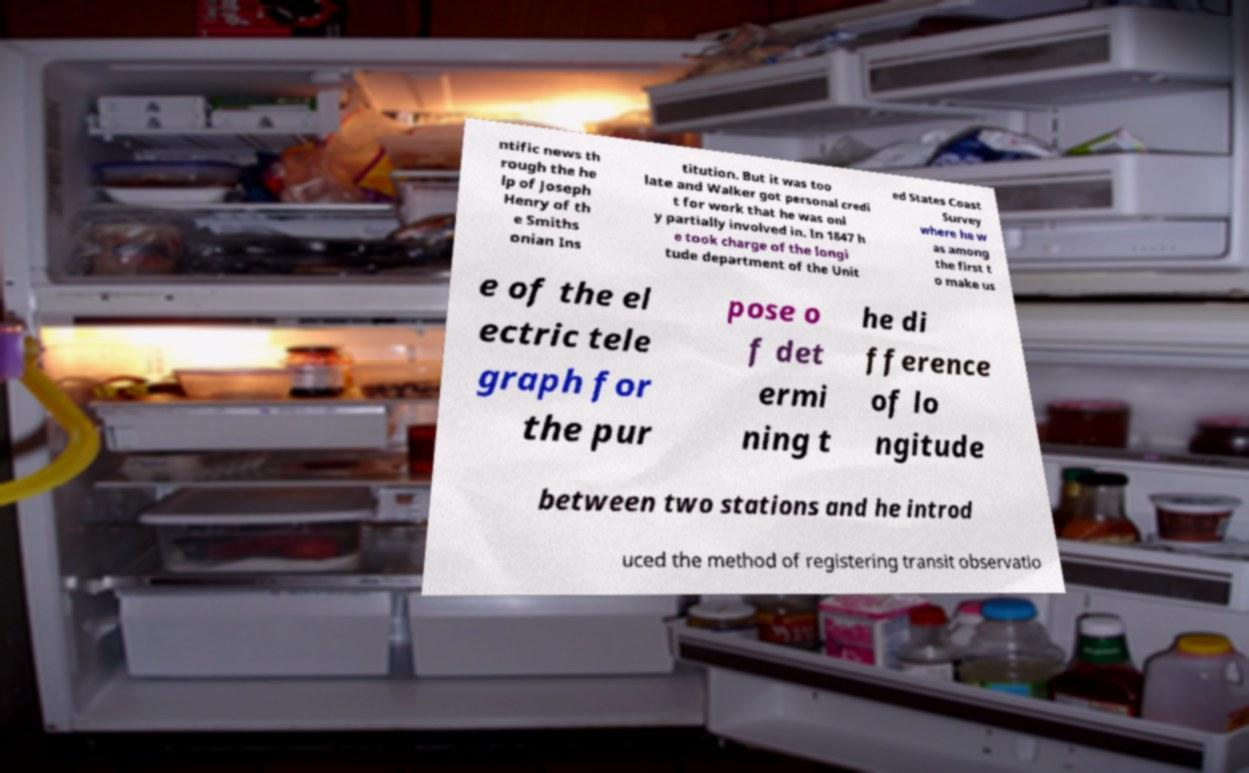I need the written content from this picture converted into text. Can you do that? ntific news th rough the he lp of Joseph Henry of th e Smiths onian Ins titution. But it was too late and Walker got personal credi t for work that he was onl y partially involved in. In 1847 h e took charge of the longi tude department of the Unit ed States Coast Survey where he w as among the first t o make us e of the el ectric tele graph for the pur pose o f det ermi ning t he di fference of lo ngitude between two stations and he introd uced the method of registering transit observatio 